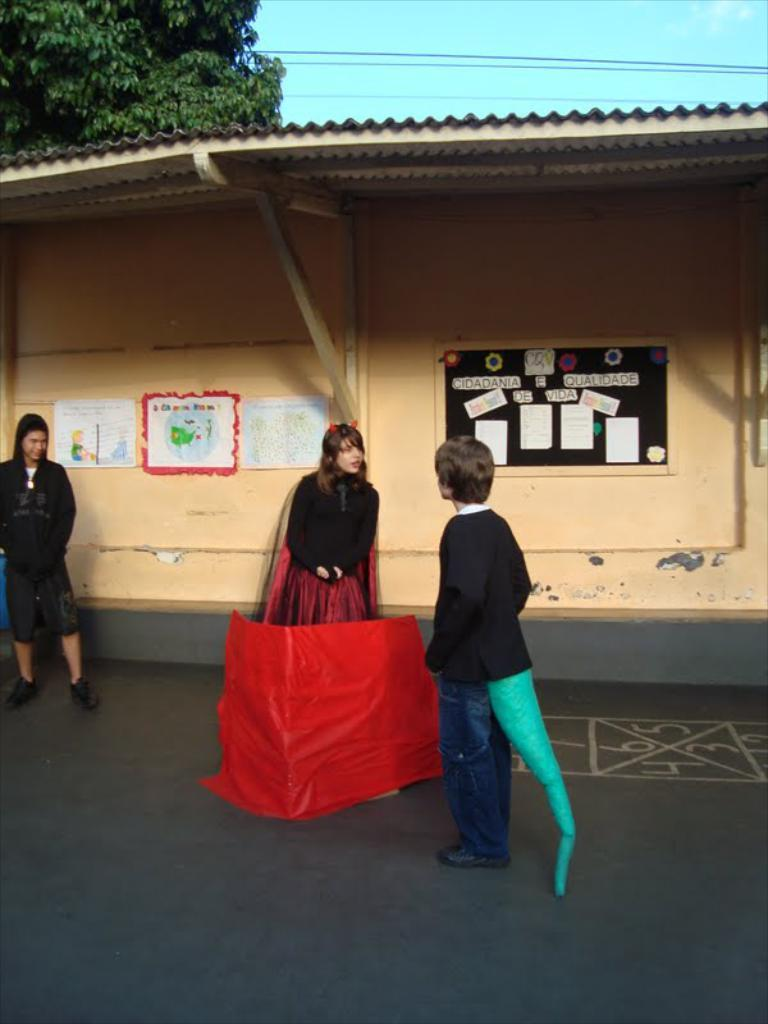How many people are present on the road in the image? There are three people on the road in the image. What color is the sheet visible in the image? The sheet in the image is red. What can be seen in the background of the image? In the background of the image, there is a shelter, posters, trees, wires, and the sky. What type of honey is being sold at the shelter in the image? There is no indication of honey or any type of sale in the image; it only shows three people on the road and various elements in the background. 